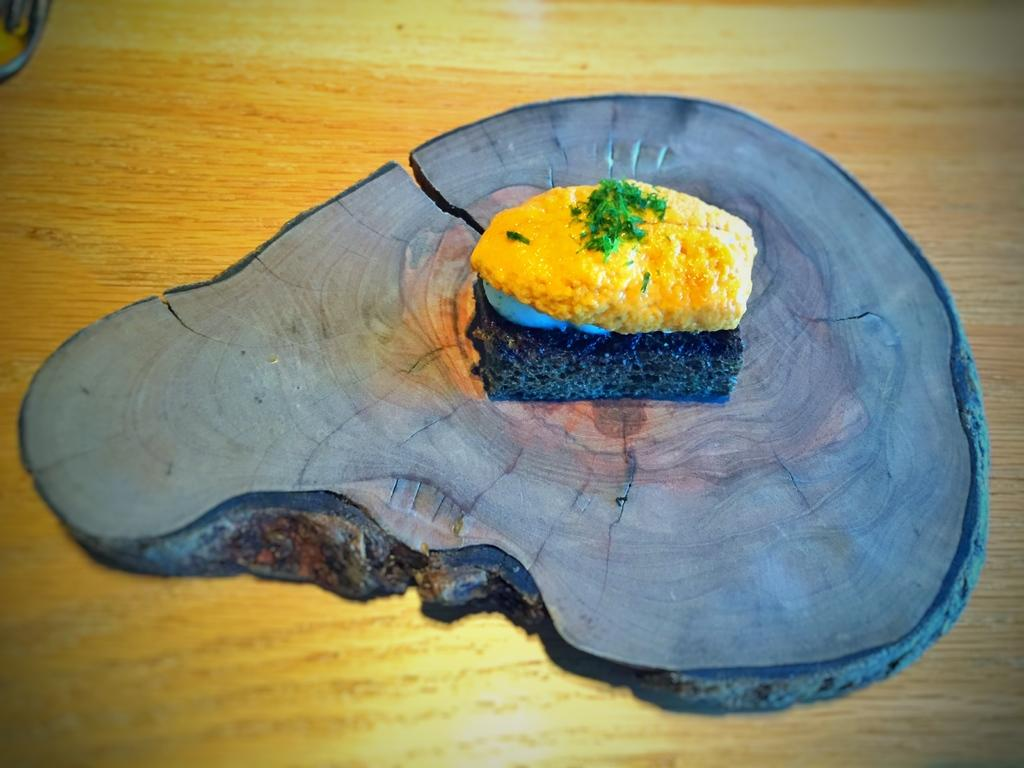What type of table is in the image? There is a wooden table in the image. What is placed on the wooden table? There is a piece of a tree trunk on the table. What is on top of the tree trunk? There is food on the tree trunk. What type of advice can be seen written on the tree trunk in the image? There is no advice written on the tree trunk in the image; it only has food on it. 